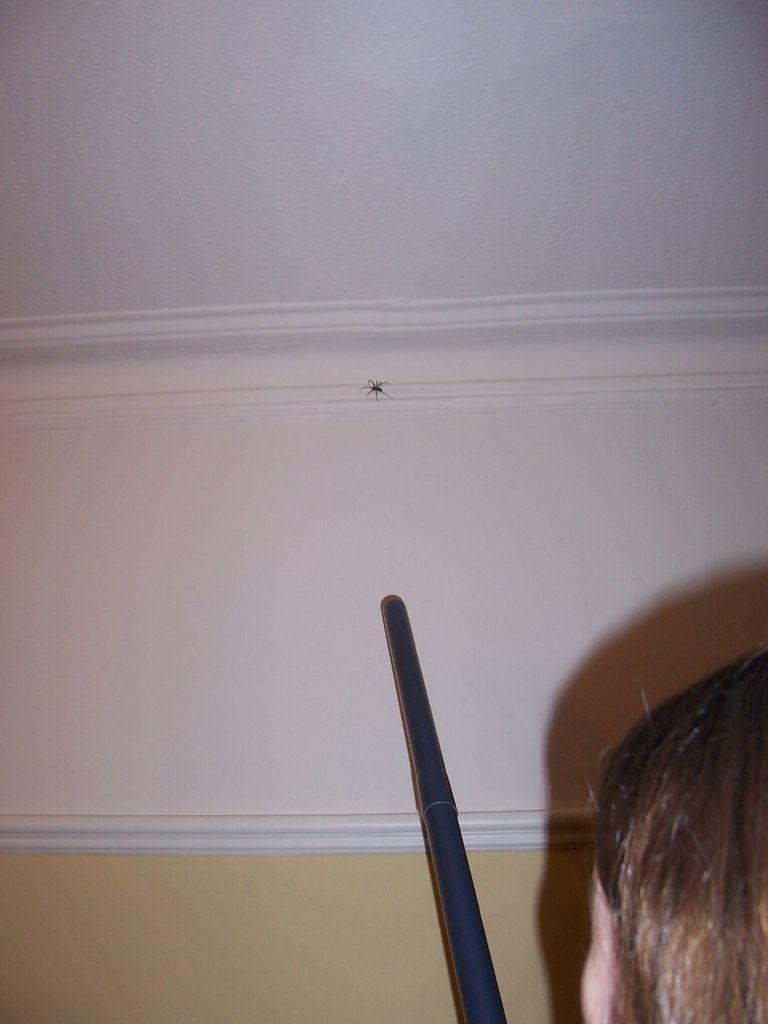Could you give a brief overview of what you see in this image? In this picture we can see a person's head and a stick in the front, in the background there is a wall, we can see a spider on the wall. 